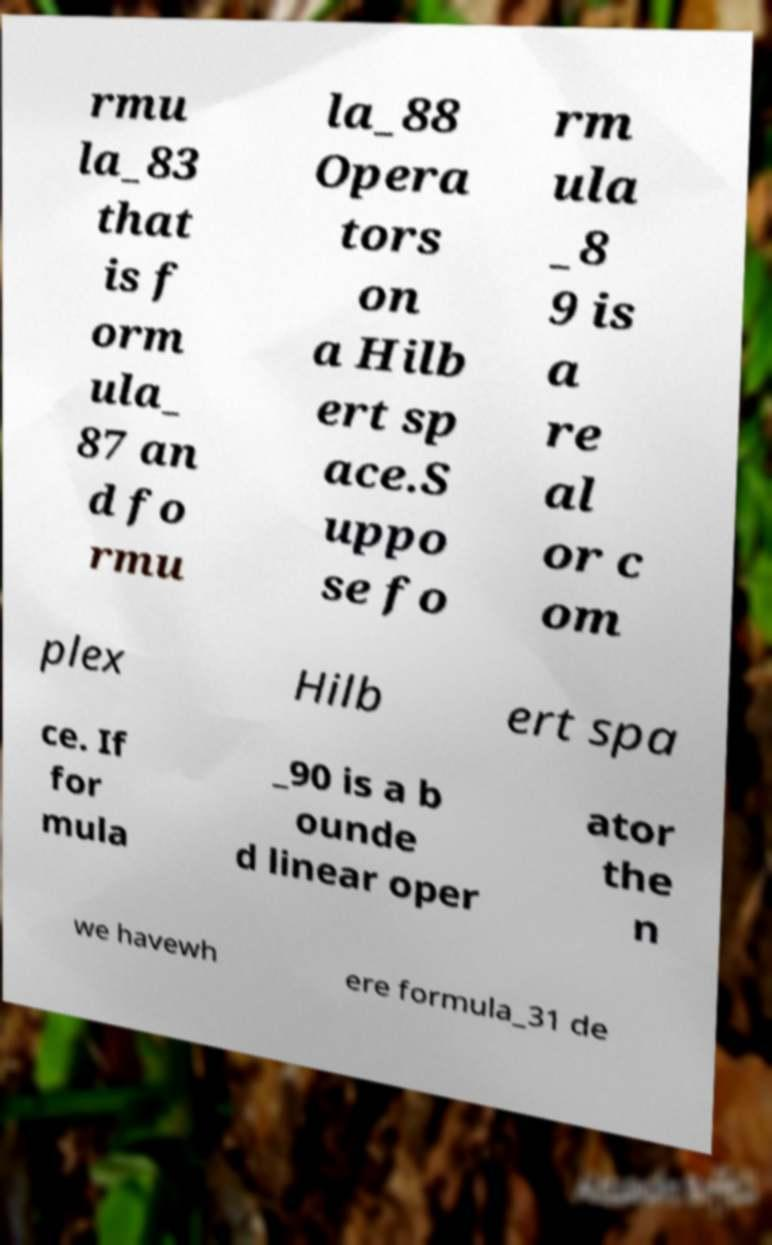Please read and relay the text visible in this image. What does it say? rmu la_83 that is f orm ula_ 87 an d fo rmu la_88 Opera tors on a Hilb ert sp ace.S uppo se fo rm ula _8 9 is a re al or c om plex Hilb ert spa ce. If for mula _90 is a b ounde d linear oper ator the n we havewh ere formula_31 de 